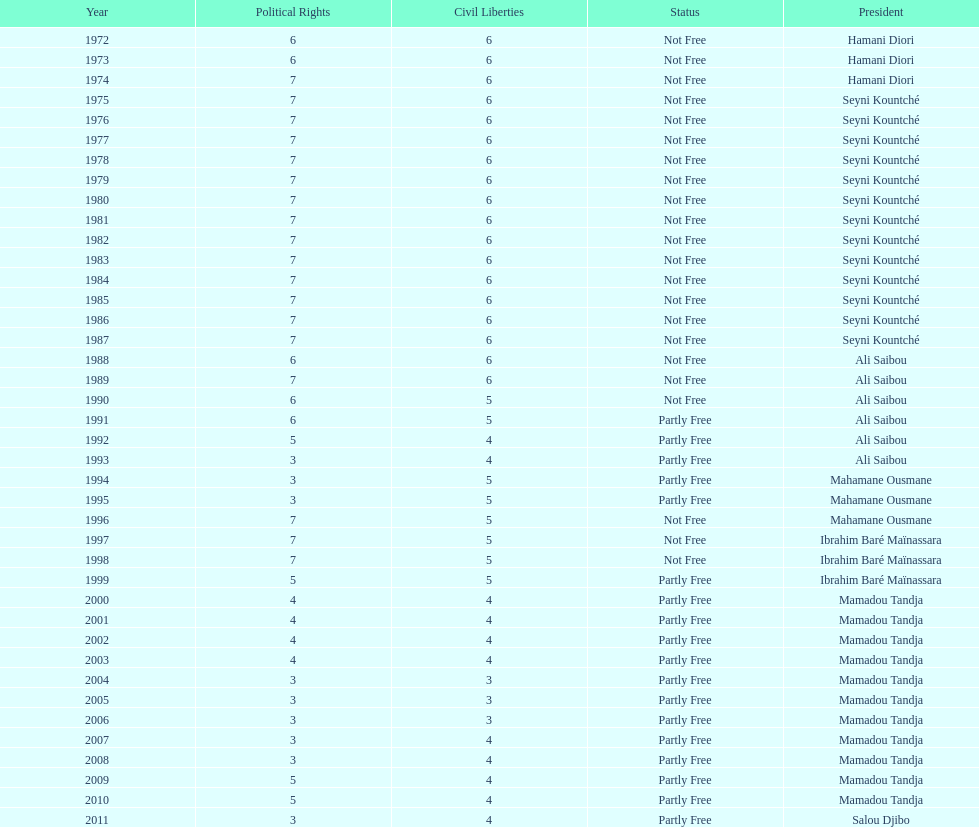How long did it take for civil liberties to decrease below 6? 18 years. 